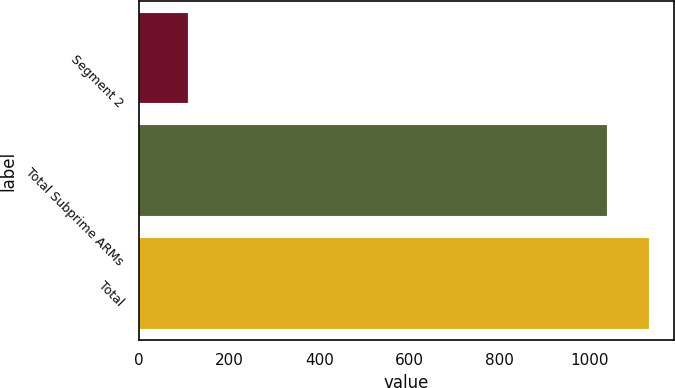<chart> <loc_0><loc_0><loc_500><loc_500><bar_chart><fcel>Segment 2<fcel>Total Subprime ARMs<fcel>Total<nl><fcel>108<fcel>1037<fcel>1129.9<nl></chart> 